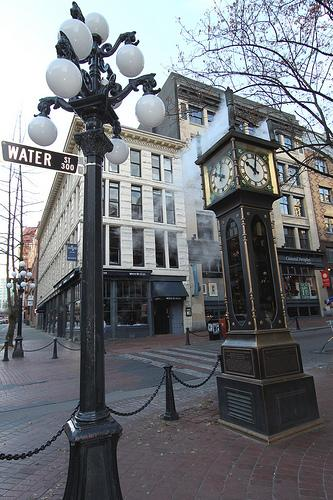What is the special feature of the windows on the white building? The windows on the white building have light reflections on them. Describe the tree in the image and its positioning. The tree has bare limbs and branches hanging over the building. What can you tell me about the elements installed above a door in the scene? There is a black awning over the door and a street sign mounted to the building. Explain the appearance of the outdoor clock. The outdoor clock has two faces, roman numerals, and steam coming out. Identify the type of the street sign and its attachment. The street sign says water street and is attached to a pole. Explain the elements found on the ground in the image. Lines, brick pavers, and a chain attached to a black pole are on the ground. What type of sidewalk is depicted in the image? Cobblestone sidewalk with squares of brick pavers. Describe the unique aspect of the street light in the image. The street light has many white globes attached to a black post. Mention some details about the chain seen in the image. The black metal chain is attached to poles, anchored to the ground, and surrounds a short post. 